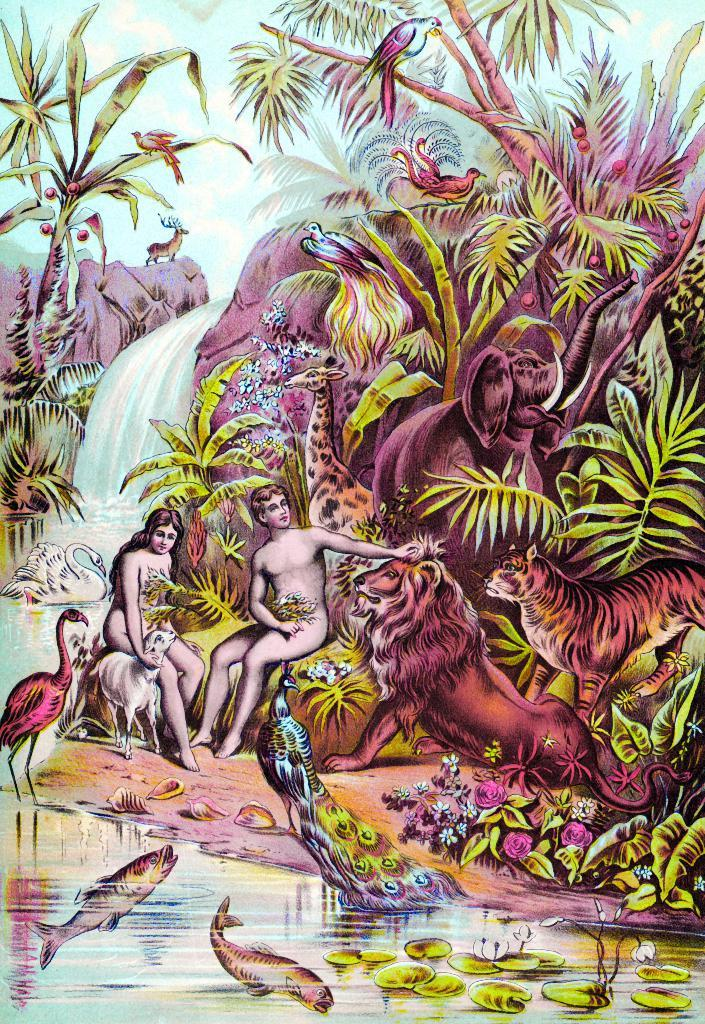What types of subjects are depicted in the paintings in the image? There are paintings of human beings, animals, and plants in the image. What other types of scenery are present in the paintings? There are other scenery pictures in the image. How does the organization of the paintings contribute to the overall comfort of the room? The provided facts do not mention any information about the organization of the paintings or the comfort of the room, so it is not possible to answer this question based on the given information. 